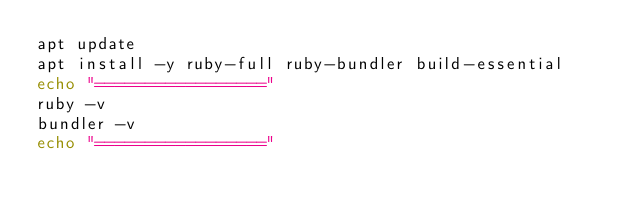Convert code to text. <code><loc_0><loc_0><loc_500><loc_500><_Bash_>apt update
apt install -y ruby-full ruby-bundler build-essential
echo "================="
ruby -v
bundler -v
echo "================="
</code> 